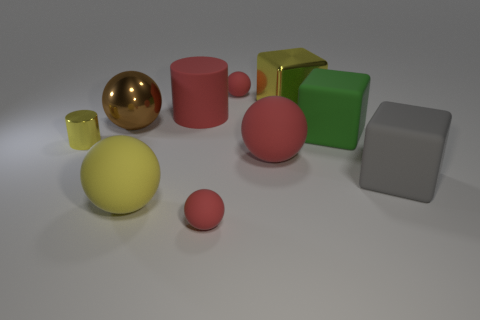Can you tell me the colors of the objects in this image? Certainly! The image features objects in various colors: a large golden sphere, a big pink cylinder, a small lime green cube, a silver cube, a yellowish sphere, and a smaller yellow cylinder, as well as a small pink sphere that matches the large pink cylinder. 